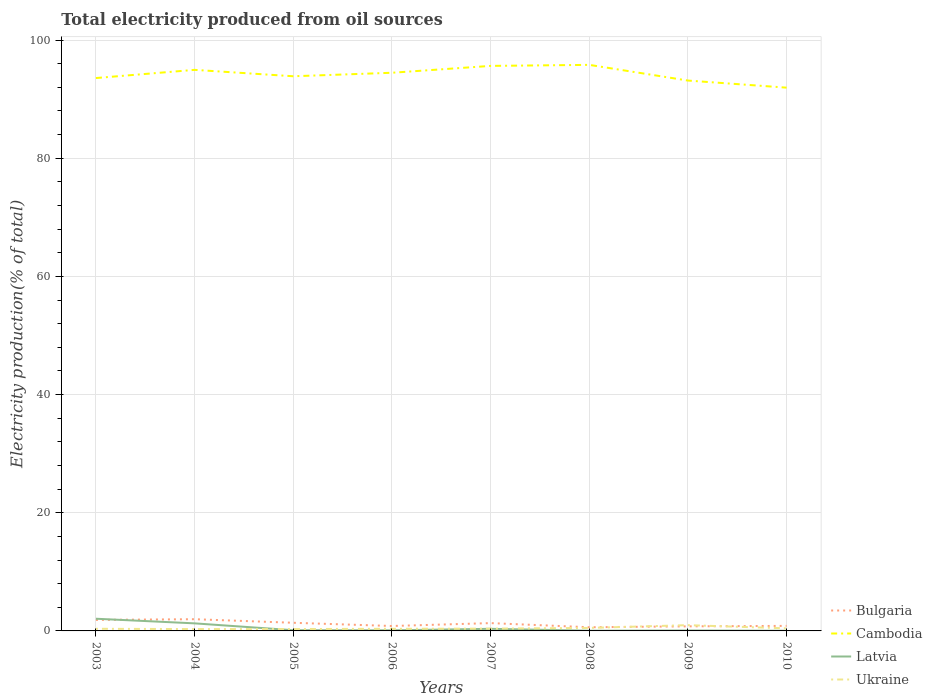How many different coloured lines are there?
Give a very brief answer. 4. Is the number of lines equal to the number of legend labels?
Provide a succinct answer. Yes. Across all years, what is the maximum total electricity produced in Latvia?
Give a very brief answer. 0.03. What is the total total electricity produced in Latvia in the graph?
Offer a very short reply. 1.96. What is the difference between the highest and the second highest total electricity produced in Latvia?
Your answer should be very brief. 2.03. Is the total electricity produced in Cambodia strictly greater than the total electricity produced in Ukraine over the years?
Your answer should be very brief. No. How many years are there in the graph?
Offer a very short reply. 8. Are the values on the major ticks of Y-axis written in scientific E-notation?
Keep it short and to the point. No. How are the legend labels stacked?
Make the answer very short. Vertical. What is the title of the graph?
Give a very brief answer. Total electricity produced from oil sources. Does "Oman" appear as one of the legend labels in the graph?
Offer a very short reply. No. What is the label or title of the X-axis?
Your answer should be very brief. Years. What is the label or title of the Y-axis?
Offer a very short reply. Electricity production(% of total). What is the Electricity production(% of total) of Bulgaria in 2003?
Provide a short and direct response. 1.86. What is the Electricity production(% of total) in Cambodia in 2003?
Offer a terse response. 93.58. What is the Electricity production(% of total) in Latvia in 2003?
Give a very brief answer. 2.06. What is the Electricity production(% of total) in Ukraine in 2003?
Offer a terse response. 0.36. What is the Electricity production(% of total) in Bulgaria in 2004?
Keep it short and to the point. 1.98. What is the Electricity production(% of total) in Cambodia in 2004?
Offer a very short reply. 94.96. What is the Electricity production(% of total) in Latvia in 2004?
Your response must be concise. 1.28. What is the Electricity production(% of total) of Ukraine in 2004?
Ensure brevity in your answer.  0.31. What is the Electricity production(% of total) in Bulgaria in 2005?
Offer a very short reply. 1.38. What is the Electricity production(% of total) in Cambodia in 2005?
Ensure brevity in your answer.  93.88. What is the Electricity production(% of total) in Latvia in 2005?
Provide a short and direct response. 0.12. What is the Electricity production(% of total) of Ukraine in 2005?
Your response must be concise. 0.32. What is the Electricity production(% of total) in Bulgaria in 2006?
Offer a very short reply. 0.83. What is the Electricity production(% of total) in Cambodia in 2006?
Make the answer very short. 94.47. What is the Electricity production(% of total) of Latvia in 2006?
Your response must be concise. 0.1. What is the Electricity production(% of total) in Ukraine in 2006?
Give a very brief answer. 0.36. What is the Electricity production(% of total) in Bulgaria in 2007?
Offer a terse response. 1.32. What is the Electricity production(% of total) of Cambodia in 2007?
Your response must be concise. 95.63. What is the Electricity production(% of total) of Latvia in 2007?
Give a very brief answer. 0.36. What is the Electricity production(% of total) of Ukraine in 2007?
Offer a terse response. 0.39. What is the Electricity production(% of total) in Bulgaria in 2008?
Your answer should be compact. 0.62. What is the Electricity production(% of total) in Cambodia in 2008?
Ensure brevity in your answer.  95.81. What is the Electricity production(% of total) of Latvia in 2008?
Make the answer very short. 0.04. What is the Electricity production(% of total) in Ukraine in 2008?
Give a very brief answer. 0.51. What is the Electricity production(% of total) of Bulgaria in 2009?
Make the answer very short. 0.77. What is the Electricity production(% of total) of Cambodia in 2009?
Offer a terse response. 93.15. What is the Electricity production(% of total) in Latvia in 2009?
Ensure brevity in your answer.  0.07. What is the Electricity production(% of total) in Ukraine in 2009?
Provide a short and direct response. 0.98. What is the Electricity production(% of total) in Bulgaria in 2010?
Offer a very short reply. 0.85. What is the Electricity production(% of total) of Cambodia in 2010?
Ensure brevity in your answer.  91.95. What is the Electricity production(% of total) in Latvia in 2010?
Give a very brief answer. 0.03. What is the Electricity production(% of total) of Ukraine in 2010?
Offer a very short reply. 0.44. Across all years, what is the maximum Electricity production(% of total) in Bulgaria?
Ensure brevity in your answer.  1.98. Across all years, what is the maximum Electricity production(% of total) in Cambodia?
Your answer should be compact. 95.81. Across all years, what is the maximum Electricity production(% of total) of Latvia?
Your answer should be very brief. 2.06. Across all years, what is the maximum Electricity production(% of total) of Ukraine?
Make the answer very short. 0.98. Across all years, what is the minimum Electricity production(% of total) of Bulgaria?
Give a very brief answer. 0.62. Across all years, what is the minimum Electricity production(% of total) in Cambodia?
Provide a succinct answer. 91.95. Across all years, what is the minimum Electricity production(% of total) of Latvia?
Your response must be concise. 0.03. Across all years, what is the minimum Electricity production(% of total) in Ukraine?
Make the answer very short. 0.31. What is the total Electricity production(% of total) in Bulgaria in the graph?
Provide a short and direct response. 9.63. What is the total Electricity production(% of total) in Cambodia in the graph?
Make the answer very short. 753.44. What is the total Electricity production(% of total) of Latvia in the graph?
Keep it short and to the point. 4.06. What is the total Electricity production(% of total) of Ukraine in the graph?
Offer a very short reply. 3.66. What is the difference between the Electricity production(% of total) in Bulgaria in 2003 and that in 2004?
Keep it short and to the point. -0.12. What is the difference between the Electricity production(% of total) in Cambodia in 2003 and that in 2004?
Ensure brevity in your answer.  -1.39. What is the difference between the Electricity production(% of total) of Latvia in 2003 and that in 2004?
Make the answer very short. 0.78. What is the difference between the Electricity production(% of total) in Ukraine in 2003 and that in 2004?
Provide a succinct answer. 0.05. What is the difference between the Electricity production(% of total) of Bulgaria in 2003 and that in 2005?
Give a very brief answer. 0.49. What is the difference between the Electricity production(% of total) of Cambodia in 2003 and that in 2005?
Provide a succinct answer. -0.3. What is the difference between the Electricity production(% of total) in Latvia in 2003 and that in 2005?
Offer a very short reply. 1.94. What is the difference between the Electricity production(% of total) of Ukraine in 2003 and that in 2005?
Offer a very short reply. 0.05. What is the difference between the Electricity production(% of total) in Bulgaria in 2003 and that in 2006?
Offer a terse response. 1.03. What is the difference between the Electricity production(% of total) of Cambodia in 2003 and that in 2006?
Ensure brevity in your answer.  -0.89. What is the difference between the Electricity production(% of total) of Latvia in 2003 and that in 2006?
Your answer should be compact. 1.96. What is the difference between the Electricity production(% of total) of Ukraine in 2003 and that in 2006?
Your answer should be very brief. 0. What is the difference between the Electricity production(% of total) of Bulgaria in 2003 and that in 2007?
Your answer should be very brief. 0.54. What is the difference between the Electricity production(% of total) of Cambodia in 2003 and that in 2007?
Your response must be concise. -2.06. What is the difference between the Electricity production(% of total) in Latvia in 2003 and that in 2007?
Provide a short and direct response. 1.71. What is the difference between the Electricity production(% of total) in Ukraine in 2003 and that in 2007?
Ensure brevity in your answer.  -0.03. What is the difference between the Electricity production(% of total) in Bulgaria in 2003 and that in 2008?
Make the answer very short. 1.24. What is the difference between the Electricity production(% of total) of Cambodia in 2003 and that in 2008?
Make the answer very short. -2.23. What is the difference between the Electricity production(% of total) of Latvia in 2003 and that in 2008?
Offer a terse response. 2.02. What is the difference between the Electricity production(% of total) in Ukraine in 2003 and that in 2008?
Make the answer very short. -0.15. What is the difference between the Electricity production(% of total) in Bulgaria in 2003 and that in 2009?
Offer a terse response. 1.09. What is the difference between the Electricity production(% of total) of Cambodia in 2003 and that in 2009?
Provide a short and direct response. 0.43. What is the difference between the Electricity production(% of total) in Latvia in 2003 and that in 2009?
Keep it short and to the point. 1.99. What is the difference between the Electricity production(% of total) of Ukraine in 2003 and that in 2009?
Your answer should be compact. -0.61. What is the difference between the Electricity production(% of total) of Bulgaria in 2003 and that in 2010?
Give a very brief answer. 1.01. What is the difference between the Electricity production(% of total) in Cambodia in 2003 and that in 2010?
Offer a terse response. 1.63. What is the difference between the Electricity production(% of total) of Latvia in 2003 and that in 2010?
Offer a terse response. 2.03. What is the difference between the Electricity production(% of total) in Ukraine in 2003 and that in 2010?
Make the answer very short. -0.08. What is the difference between the Electricity production(% of total) in Bulgaria in 2004 and that in 2005?
Ensure brevity in your answer.  0.61. What is the difference between the Electricity production(% of total) in Cambodia in 2004 and that in 2005?
Keep it short and to the point. 1.08. What is the difference between the Electricity production(% of total) of Latvia in 2004 and that in 2005?
Provide a succinct answer. 1.16. What is the difference between the Electricity production(% of total) of Ukraine in 2004 and that in 2005?
Offer a very short reply. -0. What is the difference between the Electricity production(% of total) in Bulgaria in 2004 and that in 2006?
Give a very brief answer. 1.15. What is the difference between the Electricity production(% of total) in Cambodia in 2004 and that in 2006?
Provide a succinct answer. 0.49. What is the difference between the Electricity production(% of total) in Latvia in 2004 and that in 2006?
Provide a short and direct response. 1.18. What is the difference between the Electricity production(% of total) of Ukraine in 2004 and that in 2006?
Give a very brief answer. -0.05. What is the difference between the Electricity production(% of total) in Bulgaria in 2004 and that in 2007?
Your answer should be compact. 0.66. What is the difference between the Electricity production(% of total) in Cambodia in 2004 and that in 2007?
Your answer should be very brief. -0.67. What is the difference between the Electricity production(% of total) in Latvia in 2004 and that in 2007?
Your response must be concise. 0.92. What is the difference between the Electricity production(% of total) of Ukraine in 2004 and that in 2007?
Provide a succinct answer. -0.07. What is the difference between the Electricity production(% of total) in Bulgaria in 2004 and that in 2008?
Ensure brevity in your answer.  1.36. What is the difference between the Electricity production(% of total) in Cambodia in 2004 and that in 2008?
Give a very brief answer. -0.84. What is the difference between the Electricity production(% of total) in Latvia in 2004 and that in 2008?
Provide a short and direct response. 1.24. What is the difference between the Electricity production(% of total) of Ukraine in 2004 and that in 2008?
Your response must be concise. -0.2. What is the difference between the Electricity production(% of total) in Bulgaria in 2004 and that in 2009?
Offer a terse response. 1.21. What is the difference between the Electricity production(% of total) of Cambodia in 2004 and that in 2009?
Ensure brevity in your answer.  1.81. What is the difference between the Electricity production(% of total) in Latvia in 2004 and that in 2009?
Provide a succinct answer. 1.21. What is the difference between the Electricity production(% of total) in Ukraine in 2004 and that in 2009?
Your response must be concise. -0.66. What is the difference between the Electricity production(% of total) in Bulgaria in 2004 and that in 2010?
Give a very brief answer. 1.13. What is the difference between the Electricity production(% of total) of Cambodia in 2004 and that in 2010?
Provide a succinct answer. 3.01. What is the difference between the Electricity production(% of total) in Latvia in 2004 and that in 2010?
Provide a short and direct response. 1.25. What is the difference between the Electricity production(% of total) of Ukraine in 2004 and that in 2010?
Give a very brief answer. -0.12. What is the difference between the Electricity production(% of total) of Bulgaria in 2005 and that in 2006?
Your response must be concise. 0.55. What is the difference between the Electricity production(% of total) of Cambodia in 2005 and that in 2006?
Offer a terse response. -0.59. What is the difference between the Electricity production(% of total) of Latvia in 2005 and that in 2006?
Your answer should be compact. 0.02. What is the difference between the Electricity production(% of total) of Ukraine in 2005 and that in 2006?
Ensure brevity in your answer.  -0.04. What is the difference between the Electricity production(% of total) in Bulgaria in 2005 and that in 2007?
Ensure brevity in your answer.  0.06. What is the difference between the Electricity production(% of total) of Cambodia in 2005 and that in 2007?
Keep it short and to the point. -1.75. What is the difference between the Electricity production(% of total) of Latvia in 2005 and that in 2007?
Make the answer very short. -0.23. What is the difference between the Electricity production(% of total) in Ukraine in 2005 and that in 2007?
Offer a very short reply. -0.07. What is the difference between the Electricity production(% of total) of Bulgaria in 2005 and that in 2008?
Your answer should be compact. 0.76. What is the difference between the Electricity production(% of total) in Cambodia in 2005 and that in 2008?
Give a very brief answer. -1.93. What is the difference between the Electricity production(% of total) of Latvia in 2005 and that in 2008?
Keep it short and to the point. 0.08. What is the difference between the Electricity production(% of total) of Ukraine in 2005 and that in 2008?
Your answer should be compact. -0.19. What is the difference between the Electricity production(% of total) in Bulgaria in 2005 and that in 2009?
Offer a very short reply. 0.6. What is the difference between the Electricity production(% of total) of Cambodia in 2005 and that in 2009?
Offer a terse response. 0.73. What is the difference between the Electricity production(% of total) in Latvia in 2005 and that in 2009?
Ensure brevity in your answer.  0.05. What is the difference between the Electricity production(% of total) in Ukraine in 2005 and that in 2009?
Your answer should be very brief. -0.66. What is the difference between the Electricity production(% of total) of Bulgaria in 2005 and that in 2010?
Your answer should be compact. 0.52. What is the difference between the Electricity production(% of total) of Cambodia in 2005 and that in 2010?
Offer a very short reply. 1.93. What is the difference between the Electricity production(% of total) of Latvia in 2005 and that in 2010?
Provide a short and direct response. 0.09. What is the difference between the Electricity production(% of total) of Ukraine in 2005 and that in 2010?
Keep it short and to the point. -0.12. What is the difference between the Electricity production(% of total) in Bulgaria in 2006 and that in 2007?
Your answer should be compact. -0.49. What is the difference between the Electricity production(% of total) of Cambodia in 2006 and that in 2007?
Make the answer very short. -1.16. What is the difference between the Electricity production(% of total) of Latvia in 2006 and that in 2007?
Make the answer very short. -0.25. What is the difference between the Electricity production(% of total) in Ukraine in 2006 and that in 2007?
Give a very brief answer. -0.03. What is the difference between the Electricity production(% of total) in Bulgaria in 2006 and that in 2008?
Give a very brief answer. 0.21. What is the difference between the Electricity production(% of total) of Cambodia in 2006 and that in 2008?
Keep it short and to the point. -1.34. What is the difference between the Electricity production(% of total) in Latvia in 2006 and that in 2008?
Keep it short and to the point. 0.06. What is the difference between the Electricity production(% of total) of Ukraine in 2006 and that in 2008?
Your answer should be compact. -0.15. What is the difference between the Electricity production(% of total) in Bulgaria in 2006 and that in 2009?
Your response must be concise. 0.06. What is the difference between the Electricity production(% of total) of Cambodia in 2006 and that in 2009?
Provide a succinct answer. 1.32. What is the difference between the Electricity production(% of total) in Latvia in 2006 and that in 2009?
Offer a very short reply. 0.03. What is the difference between the Electricity production(% of total) in Ukraine in 2006 and that in 2009?
Your answer should be compact. -0.62. What is the difference between the Electricity production(% of total) of Bulgaria in 2006 and that in 2010?
Give a very brief answer. -0.02. What is the difference between the Electricity production(% of total) in Cambodia in 2006 and that in 2010?
Offer a terse response. 2.52. What is the difference between the Electricity production(% of total) of Latvia in 2006 and that in 2010?
Give a very brief answer. 0.07. What is the difference between the Electricity production(% of total) in Ukraine in 2006 and that in 2010?
Make the answer very short. -0.08. What is the difference between the Electricity production(% of total) of Bulgaria in 2007 and that in 2008?
Give a very brief answer. 0.7. What is the difference between the Electricity production(% of total) of Cambodia in 2007 and that in 2008?
Your answer should be compact. -0.17. What is the difference between the Electricity production(% of total) in Latvia in 2007 and that in 2008?
Keep it short and to the point. 0.32. What is the difference between the Electricity production(% of total) of Ukraine in 2007 and that in 2008?
Your response must be concise. -0.12. What is the difference between the Electricity production(% of total) in Bulgaria in 2007 and that in 2009?
Offer a terse response. 0.55. What is the difference between the Electricity production(% of total) in Cambodia in 2007 and that in 2009?
Your answer should be compact. 2.48. What is the difference between the Electricity production(% of total) in Latvia in 2007 and that in 2009?
Offer a very short reply. 0.28. What is the difference between the Electricity production(% of total) of Ukraine in 2007 and that in 2009?
Your response must be concise. -0.59. What is the difference between the Electricity production(% of total) of Bulgaria in 2007 and that in 2010?
Your answer should be compact. 0.47. What is the difference between the Electricity production(% of total) of Cambodia in 2007 and that in 2010?
Offer a terse response. 3.68. What is the difference between the Electricity production(% of total) in Latvia in 2007 and that in 2010?
Offer a terse response. 0.33. What is the difference between the Electricity production(% of total) of Ukraine in 2007 and that in 2010?
Your response must be concise. -0.05. What is the difference between the Electricity production(% of total) in Bulgaria in 2008 and that in 2009?
Offer a very short reply. -0.15. What is the difference between the Electricity production(% of total) of Cambodia in 2008 and that in 2009?
Your answer should be compact. 2.66. What is the difference between the Electricity production(% of total) of Latvia in 2008 and that in 2009?
Offer a terse response. -0.03. What is the difference between the Electricity production(% of total) of Ukraine in 2008 and that in 2009?
Your response must be concise. -0.47. What is the difference between the Electricity production(% of total) in Bulgaria in 2008 and that in 2010?
Make the answer very short. -0.23. What is the difference between the Electricity production(% of total) in Cambodia in 2008 and that in 2010?
Offer a terse response. 3.86. What is the difference between the Electricity production(% of total) of Latvia in 2008 and that in 2010?
Your answer should be compact. 0.01. What is the difference between the Electricity production(% of total) of Ukraine in 2008 and that in 2010?
Offer a very short reply. 0.07. What is the difference between the Electricity production(% of total) in Bulgaria in 2009 and that in 2010?
Your response must be concise. -0.08. What is the difference between the Electricity production(% of total) of Cambodia in 2009 and that in 2010?
Your answer should be very brief. 1.2. What is the difference between the Electricity production(% of total) in Latvia in 2009 and that in 2010?
Your answer should be compact. 0.04. What is the difference between the Electricity production(% of total) in Ukraine in 2009 and that in 2010?
Your answer should be very brief. 0.54. What is the difference between the Electricity production(% of total) in Bulgaria in 2003 and the Electricity production(% of total) in Cambodia in 2004?
Your answer should be very brief. -93.1. What is the difference between the Electricity production(% of total) of Bulgaria in 2003 and the Electricity production(% of total) of Latvia in 2004?
Your answer should be compact. 0.58. What is the difference between the Electricity production(% of total) of Bulgaria in 2003 and the Electricity production(% of total) of Ukraine in 2004?
Provide a short and direct response. 1.55. What is the difference between the Electricity production(% of total) of Cambodia in 2003 and the Electricity production(% of total) of Latvia in 2004?
Your response must be concise. 92.3. What is the difference between the Electricity production(% of total) of Cambodia in 2003 and the Electricity production(% of total) of Ukraine in 2004?
Keep it short and to the point. 93.26. What is the difference between the Electricity production(% of total) of Latvia in 2003 and the Electricity production(% of total) of Ukraine in 2004?
Give a very brief answer. 1.75. What is the difference between the Electricity production(% of total) of Bulgaria in 2003 and the Electricity production(% of total) of Cambodia in 2005?
Your answer should be very brief. -92.02. What is the difference between the Electricity production(% of total) in Bulgaria in 2003 and the Electricity production(% of total) in Latvia in 2005?
Provide a succinct answer. 1.74. What is the difference between the Electricity production(% of total) in Bulgaria in 2003 and the Electricity production(% of total) in Ukraine in 2005?
Provide a succinct answer. 1.55. What is the difference between the Electricity production(% of total) in Cambodia in 2003 and the Electricity production(% of total) in Latvia in 2005?
Provide a succinct answer. 93.46. What is the difference between the Electricity production(% of total) in Cambodia in 2003 and the Electricity production(% of total) in Ukraine in 2005?
Your answer should be compact. 93.26. What is the difference between the Electricity production(% of total) in Latvia in 2003 and the Electricity production(% of total) in Ukraine in 2005?
Offer a terse response. 1.75. What is the difference between the Electricity production(% of total) of Bulgaria in 2003 and the Electricity production(% of total) of Cambodia in 2006?
Keep it short and to the point. -92.61. What is the difference between the Electricity production(% of total) in Bulgaria in 2003 and the Electricity production(% of total) in Latvia in 2006?
Give a very brief answer. 1.76. What is the difference between the Electricity production(% of total) in Bulgaria in 2003 and the Electricity production(% of total) in Ukraine in 2006?
Offer a terse response. 1.5. What is the difference between the Electricity production(% of total) in Cambodia in 2003 and the Electricity production(% of total) in Latvia in 2006?
Offer a very short reply. 93.48. What is the difference between the Electricity production(% of total) of Cambodia in 2003 and the Electricity production(% of total) of Ukraine in 2006?
Provide a short and direct response. 93.22. What is the difference between the Electricity production(% of total) in Latvia in 2003 and the Electricity production(% of total) in Ukraine in 2006?
Make the answer very short. 1.7. What is the difference between the Electricity production(% of total) in Bulgaria in 2003 and the Electricity production(% of total) in Cambodia in 2007?
Offer a very short reply. -93.77. What is the difference between the Electricity production(% of total) in Bulgaria in 2003 and the Electricity production(% of total) in Latvia in 2007?
Provide a succinct answer. 1.51. What is the difference between the Electricity production(% of total) in Bulgaria in 2003 and the Electricity production(% of total) in Ukraine in 2007?
Your answer should be very brief. 1.48. What is the difference between the Electricity production(% of total) of Cambodia in 2003 and the Electricity production(% of total) of Latvia in 2007?
Offer a terse response. 93.22. What is the difference between the Electricity production(% of total) in Cambodia in 2003 and the Electricity production(% of total) in Ukraine in 2007?
Your answer should be very brief. 93.19. What is the difference between the Electricity production(% of total) in Latvia in 2003 and the Electricity production(% of total) in Ukraine in 2007?
Offer a very short reply. 1.68. What is the difference between the Electricity production(% of total) in Bulgaria in 2003 and the Electricity production(% of total) in Cambodia in 2008?
Keep it short and to the point. -93.94. What is the difference between the Electricity production(% of total) of Bulgaria in 2003 and the Electricity production(% of total) of Latvia in 2008?
Your answer should be compact. 1.83. What is the difference between the Electricity production(% of total) of Bulgaria in 2003 and the Electricity production(% of total) of Ukraine in 2008?
Keep it short and to the point. 1.35. What is the difference between the Electricity production(% of total) of Cambodia in 2003 and the Electricity production(% of total) of Latvia in 2008?
Ensure brevity in your answer.  93.54. What is the difference between the Electricity production(% of total) of Cambodia in 2003 and the Electricity production(% of total) of Ukraine in 2008?
Offer a very short reply. 93.07. What is the difference between the Electricity production(% of total) of Latvia in 2003 and the Electricity production(% of total) of Ukraine in 2008?
Provide a short and direct response. 1.55. What is the difference between the Electricity production(% of total) in Bulgaria in 2003 and the Electricity production(% of total) in Cambodia in 2009?
Your response must be concise. -91.29. What is the difference between the Electricity production(% of total) of Bulgaria in 2003 and the Electricity production(% of total) of Latvia in 2009?
Your response must be concise. 1.79. What is the difference between the Electricity production(% of total) in Bulgaria in 2003 and the Electricity production(% of total) in Ukraine in 2009?
Offer a terse response. 0.89. What is the difference between the Electricity production(% of total) in Cambodia in 2003 and the Electricity production(% of total) in Latvia in 2009?
Give a very brief answer. 93.51. What is the difference between the Electricity production(% of total) of Cambodia in 2003 and the Electricity production(% of total) of Ukraine in 2009?
Provide a succinct answer. 92.6. What is the difference between the Electricity production(% of total) in Latvia in 2003 and the Electricity production(% of total) in Ukraine in 2009?
Provide a short and direct response. 1.09. What is the difference between the Electricity production(% of total) of Bulgaria in 2003 and the Electricity production(% of total) of Cambodia in 2010?
Provide a short and direct response. -90.09. What is the difference between the Electricity production(% of total) in Bulgaria in 2003 and the Electricity production(% of total) in Latvia in 2010?
Provide a short and direct response. 1.83. What is the difference between the Electricity production(% of total) in Bulgaria in 2003 and the Electricity production(% of total) in Ukraine in 2010?
Keep it short and to the point. 1.43. What is the difference between the Electricity production(% of total) in Cambodia in 2003 and the Electricity production(% of total) in Latvia in 2010?
Provide a succinct answer. 93.55. What is the difference between the Electricity production(% of total) in Cambodia in 2003 and the Electricity production(% of total) in Ukraine in 2010?
Ensure brevity in your answer.  93.14. What is the difference between the Electricity production(% of total) in Latvia in 2003 and the Electricity production(% of total) in Ukraine in 2010?
Your answer should be very brief. 1.63. What is the difference between the Electricity production(% of total) of Bulgaria in 2004 and the Electricity production(% of total) of Cambodia in 2005?
Keep it short and to the point. -91.9. What is the difference between the Electricity production(% of total) of Bulgaria in 2004 and the Electricity production(% of total) of Latvia in 2005?
Provide a short and direct response. 1.86. What is the difference between the Electricity production(% of total) of Bulgaria in 2004 and the Electricity production(% of total) of Ukraine in 2005?
Give a very brief answer. 1.67. What is the difference between the Electricity production(% of total) in Cambodia in 2004 and the Electricity production(% of total) in Latvia in 2005?
Provide a succinct answer. 94.84. What is the difference between the Electricity production(% of total) of Cambodia in 2004 and the Electricity production(% of total) of Ukraine in 2005?
Give a very brief answer. 94.65. What is the difference between the Electricity production(% of total) in Latvia in 2004 and the Electricity production(% of total) in Ukraine in 2005?
Your answer should be very brief. 0.96. What is the difference between the Electricity production(% of total) in Bulgaria in 2004 and the Electricity production(% of total) in Cambodia in 2006?
Your response must be concise. -92.49. What is the difference between the Electricity production(% of total) in Bulgaria in 2004 and the Electricity production(% of total) in Latvia in 2006?
Your answer should be compact. 1.88. What is the difference between the Electricity production(% of total) of Bulgaria in 2004 and the Electricity production(% of total) of Ukraine in 2006?
Your response must be concise. 1.62. What is the difference between the Electricity production(% of total) in Cambodia in 2004 and the Electricity production(% of total) in Latvia in 2006?
Provide a succinct answer. 94.86. What is the difference between the Electricity production(% of total) of Cambodia in 2004 and the Electricity production(% of total) of Ukraine in 2006?
Your response must be concise. 94.6. What is the difference between the Electricity production(% of total) of Latvia in 2004 and the Electricity production(% of total) of Ukraine in 2006?
Keep it short and to the point. 0.92. What is the difference between the Electricity production(% of total) in Bulgaria in 2004 and the Electricity production(% of total) in Cambodia in 2007?
Make the answer very short. -93.65. What is the difference between the Electricity production(% of total) of Bulgaria in 2004 and the Electricity production(% of total) of Latvia in 2007?
Provide a succinct answer. 1.63. What is the difference between the Electricity production(% of total) of Bulgaria in 2004 and the Electricity production(% of total) of Ukraine in 2007?
Offer a very short reply. 1.6. What is the difference between the Electricity production(% of total) in Cambodia in 2004 and the Electricity production(% of total) in Latvia in 2007?
Your response must be concise. 94.61. What is the difference between the Electricity production(% of total) in Cambodia in 2004 and the Electricity production(% of total) in Ukraine in 2007?
Your response must be concise. 94.58. What is the difference between the Electricity production(% of total) in Latvia in 2004 and the Electricity production(% of total) in Ukraine in 2007?
Your answer should be compact. 0.89. What is the difference between the Electricity production(% of total) in Bulgaria in 2004 and the Electricity production(% of total) in Cambodia in 2008?
Your response must be concise. -93.82. What is the difference between the Electricity production(% of total) in Bulgaria in 2004 and the Electricity production(% of total) in Latvia in 2008?
Give a very brief answer. 1.95. What is the difference between the Electricity production(% of total) in Bulgaria in 2004 and the Electricity production(% of total) in Ukraine in 2008?
Offer a terse response. 1.47. What is the difference between the Electricity production(% of total) in Cambodia in 2004 and the Electricity production(% of total) in Latvia in 2008?
Make the answer very short. 94.93. What is the difference between the Electricity production(% of total) in Cambodia in 2004 and the Electricity production(% of total) in Ukraine in 2008?
Provide a succinct answer. 94.45. What is the difference between the Electricity production(% of total) of Latvia in 2004 and the Electricity production(% of total) of Ukraine in 2008?
Your response must be concise. 0.77. What is the difference between the Electricity production(% of total) in Bulgaria in 2004 and the Electricity production(% of total) in Cambodia in 2009?
Make the answer very short. -91.17. What is the difference between the Electricity production(% of total) of Bulgaria in 2004 and the Electricity production(% of total) of Latvia in 2009?
Give a very brief answer. 1.91. What is the difference between the Electricity production(% of total) in Bulgaria in 2004 and the Electricity production(% of total) in Ukraine in 2009?
Ensure brevity in your answer.  1.01. What is the difference between the Electricity production(% of total) in Cambodia in 2004 and the Electricity production(% of total) in Latvia in 2009?
Ensure brevity in your answer.  94.89. What is the difference between the Electricity production(% of total) in Cambodia in 2004 and the Electricity production(% of total) in Ukraine in 2009?
Provide a short and direct response. 93.99. What is the difference between the Electricity production(% of total) of Latvia in 2004 and the Electricity production(% of total) of Ukraine in 2009?
Make the answer very short. 0.3. What is the difference between the Electricity production(% of total) in Bulgaria in 2004 and the Electricity production(% of total) in Cambodia in 2010?
Your answer should be compact. -89.97. What is the difference between the Electricity production(% of total) in Bulgaria in 2004 and the Electricity production(% of total) in Latvia in 2010?
Make the answer very short. 1.95. What is the difference between the Electricity production(% of total) of Bulgaria in 2004 and the Electricity production(% of total) of Ukraine in 2010?
Offer a terse response. 1.55. What is the difference between the Electricity production(% of total) of Cambodia in 2004 and the Electricity production(% of total) of Latvia in 2010?
Give a very brief answer. 94.93. What is the difference between the Electricity production(% of total) of Cambodia in 2004 and the Electricity production(% of total) of Ukraine in 2010?
Offer a very short reply. 94.53. What is the difference between the Electricity production(% of total) in Latvia in 2004 and the Electricity production(% of total) in Ukraine in 2010?
Offer a very short reply. 0.84. What is the difference between the Electricity production(% of total) of Bulgaria in 2005 and the Electricity production(% of total) of Cambodia in 2006?
Your answer should be compact. -93.09. What is the difference between the Electricity production(% of total) of Bulgaria in 2005 and the Electricity production(% of total) of Latvia in 2006?
Keep it short and to the point. 1.28. What is the difference between the Electricity production(% of total) in Bulgaria in 2005 and the Electricity production(% of total) in Ukraine in 2006?
Your answer should be compact. 1.02. What is the difference between the Electricity production(% of total) of Cambodia in 2005 and the Electricity production(% of total) of Latvia in 2006?
Ensure brevity in your answer.  93.78. What is the difference between the Electricity production(% of total) of Cambodia in 2005 and the Electricity production(% of total) of Ukraine in 2006?
Provide a succinct answer. 93.52. What is the difference between the Electricity production(% of total) of Latvia in 2005 and the Electricity production(% of total) of Ukraine in 2006?
Your response must be concise. -0.24. What is the difference between the Electricity production(% of total) in Bulgaria in 2005 and the Electricity production(% of total) in Cambodia in 2007?
Provide a short and direct response. -94.26. What is the difference between the Electricity production(% of total) of Bulgaria in 2005 and the Electricity production(% of total) of Latvia in 2007?
Make the answer very short. 1.02. What is the difference between the Electricity production(% of total) of Bulgaria in 2005 and the Electricity production(% of total) of Ukraine in 2007?
Provide a short and direct response. 0.99. What is the difference between the Electricity production(% of total) in Cambodia in 2005 and the Electricity production(% of total) in Latvia in 2007?
Offer a very short reply. 93.52. What is the difference between the Electricity production(% of total) of Cambodia in 2005 and the Electricity production(% of total) of Ukraine in 2007?
Your answer should be very brief. 93.49. What is the difference between the Electricity production(% of total) in Latvia in 2005 and the Electricity production(% of total) in Ukraine in 2007?
Your answer should be compact. -0.26. What is the difference between the Electricity production(% of total) of Bulgaria in 2005 and the Electricity production(% of total) of Cambodia in 2008?
Your response must be concise. -94.43. What is the difference between the Electricity production(% of total) in Bulgaria in 2005 and the Electricity production(% of total) in Latvia in 2008?
Your response must be concise. 1.34. What is the difference between the Electricity production(% of total) in Bulgaria in 2005 and the Electricity production(% of total) in Ukraine in 2008?
Your answer should be very brief. 0.87. What is the difference between the Electricity production(% of total) of Cambodia in 2005 and the Electricity production(% of total) of Latvia in 2008?
Keep it short and to the point. 93.84. What is the difference between the Electricity production(% of total) of Cambodia in 2005 and the Electricity production(% of total) of Ukraine in 2008?
Your response must be concise. 93.37. What is the difference between the Electricity production(% of total) in Latvia in 2005 and the Electricity production(% of total) in Ukraine in 2008?
Your answer should be compact. -0.39. What is the difference between the Electricity production(% of total) of Bulgaria in 2005 and the Electricity production(% of total) of Cambodia in 2009?
Offer a very short reply. -91.77. What is the difference between the Electricity production(% of total) of Bulgaria in 2005 and the Electricity production(% of total) of Latvia in 2009?
Your response must be concise. 1.31. What is the difference between the Electricity production(% of total) in Bulgaria in 2005 and the Electricity production(% of total) in Ukraine in 2009?
Provide a succinct answer. 0.4. What is the difference between the Electricity production(% of total) of Cambodia in 2005 and the Electricity production(% of total) of Latvia in 2009?
Your response must be concise. 93.81. What is the difference between the Electricity production(% of total) in Cambodia in 2005 and the Electricity production(% of total) in Ukraine in 2009?
Make the answer very short. 92.9. What is the difference between the Electricity production(% of total) of Latvia in 2005 and the Electricity production(% of total) of Ukraine in 2009?
Your answer should be very brief. -0.85. What is the difference between the Electricity production(% of total) of Bulgaria in 2005 and the Electricity production(% of total) of Cambodia in 2010?
Offer a very short reply. -90.57. What is the difference between the Electricity production(% of total) of Bulgaria in 2005 and the Electricity production(% of total) of Latvia in 2010?
Make the answer very short. 1.35. What is the difference between the Electricity production(% of total) of Bulgaria in 2005 and the Electricity production(% of total) of Ukraine in 2010?
Your response must be concise. 0.94. What is the difference between the Electricity production(% of total) of Cambodia in 2005 and the Electricity production(% of total) of Latvia in 2010?
Give a very brief answer. 93.85. What is the difference between the Electricity production(% of total) of Cambodia in 2005 and the Electricity production(% of total) of Ukraine in 2010?
Your response must be concise. 93.44. What is the difference between the Electricity production(% of total) of Latvia in 2005 and the Electricity production(% of total) of Ukraine in 2010?
Make the answer very short. -0.31. What is the difference between the Electricity production(% of total) of Bulgaria in 2006 and the Electricity production(% of total) of Cambodia in 2007?
Offer a terse response. -94.8. What is the difference between the Electricity production(% of total) in Bulgaria in 2006 and the Electricity production(% of total) in Latvia in 2007?
Your answer should be very brief. 0.48. What is the difference between the Electricity production(% of total) in Bulgaria in 2006 and the Electricity production(% of total) in Ukraine in 2007?
Make the answer very short. 0.45. What is the difference between the Electricity production(% of total) of Cambodia in 2006 and the Electricity production(% of total) of Latvia in 2007?
Your answer should be compact. 94.12. What is the difference between the Electricity production(% of total) of Cambodia in 2006 and the Electricity production(% of total) of Ukraine in 2007?
Your answer should be compact. 94.09. What is the difference between the Electricity production(% of total) of Latvia in 2006 and the Electricity production(% of total) of Ukraine in 2007?
Provide a succinct answer. -0.28. What is the difference between the Electricity production(% of total) in Bulgaria in 2006 and the Electricity production(% of total) in Cambodia in 2008?
Provide a short and direct response. -94.97. What is the difference between the Electricity production(% of total) of Bulgaria in 2006 and the Electricity production(% of total) of Latvia in 2008?
Give a very brief answer. 0.8. What is the difference between the Electricity production(% of total) of Bulgaria in 2006 and the Electricity production(% of total) of Ukraine in 2008?
Provide a succinct answer. 0.32. What is the difference between the Electricity production(% of total) in Cambodia in 2006 and the Electricity production(% of total) in Latvia in 2008?
Your answer should be very brief. 94.43. What is the difference between the Electricity production(% of total) in Cambodia in 2006 and the Electricity production(% of total) in Ukraine in 2008?
Offer a terse response. 93.96. What is the difference between the Electricity production(% of total) of Latvia in 2006 and the Electricity production(% of total) of Ukraine in 2008?
Your answer should be compact. -0.41. What is the difference between the Electricity production(% of total) of Bulgaria in 2006 and the Electricity production(% of total) of Cambodia in 2009?
Your answer should be very brief. -92.32. What is the difference between the Electricity production(% of total) of Bulgaria in 2006 and the Electricity production(% of total) of Latvia in 2009?
Keep it short and to the point. 0.76. What is the difference between the Electricity production(% of total) of Bulgaria in 2006 and the Electricity production(% of total) of Ukraine in 2009?
Make the answer very short. -0.14. What is the difference between the Electricity production(% of total) in Cambodia in 2006 and the Electricity production(% of total) in Latvia in 2009?
Provide a short and direct response. 94.4. What is the difference between the Electricity production(% of total) of Cambodia in 2006 and the Electricity production(% of total) of Ukraine in 2009?
Ensure brevity in your answer.  93.5. What is the difference between the Electricity production(% of total) of Latvia in 2006 and the Electricity production(% of total) of Ukraine in 2009?
Keep it short and to the point. -0.87. What is the difference between the Electricity production(% of total) in Bulgaria in 2006 and the Electricity production(% of total) in Cambodia in 2010?
Your answer should be very brief. -91.12. What is the difference between the Electricity production(% of total) of Bulgaria in 2006 and the Electricity production(% of total) of Latvia in 2010?
Your answer should be very brief. 0.8. What is the difference between the Electricity production(% of total) in Bulgaria in 2006 and the Electricity production(% of total) in Ukraine in 2010?
Offer a very short reply. 0.4. What is the difference between the Electricity production(% of total) of Cambodia in 2006 and the Electricity production(% of total) of Latvia in 2010?
Offer a very short reply. 94.44. What is the difference between the Electricity production(% of total) in Cambodia in 2006 and the Electricity production(% of total) in Ukraine in 2010?
Provide a succinct answer. 94.04. What is the difference between the Electricity production(% of total) of Latvia in 2006 and the Electricity production(% of total) of Ukraine in 2010?
Offer a very short reply. -0.33. What is the difference between the Electricity production(% of total) in Bulgaria in 2007 and the Electricity production(% of total) in Cambodia in 2008?
Provide a short and direct response. -94.49. What is the difference between the Electricity production(% of total) in Bulgaria in 2007 and the Electricity production(% of total) in Latvia in 2008?
Offer a terse response. 1.28. What is the difference between the Electricity production(% of total) in Bulgaria in 2007 and the Electricity production(% of total) in Ukraine in 2008?
Provide a short and direct response. 0.81. What is the difference between the Electricity production(% of total) in Cambodia in 2007 and the Electricity production(% of total) in Latvia in 2008?
Your answer should be very brief. 95.6. What is the difference between the Electricity production(% of total) of Cambodia in 2007 and the Electricity production(% of total) of Ukraine in 2008?
Give a very brief answer. 95.12. What is the difference between the Electricity production(% of total) in Latvia in 2007 and the Electricity production(% of total) in Ukraine in 2008?
Ensure brevity in your answer.  -0.15. What is the difference between the Electricity production(% of total) of Bulgaria in 2007 and the Electricity production(% of total) of Cambodia in 2009?
Keep it short and to the point. -91.83. What is the difference between the Electricity production(% of total) of Bulgaria in 2007 and the Electricity production(% of total) of Latvia in 2009?
Provide a short and direct response. 1.25. What is the difference between the Electricity production(% of total) in Bulgaria in 2007 and the Electricity production(% of total) in Ukraine in 2009?
Your answer should be compact. 0.35. What is the difference between the Electricity production(% of total) in Cambodia in 2007 and the Electricity production(% of total) in Latvia in 2009?
Your answer should be compact. 95.56. What is the difference between the Electricity production(% of total) in Cambodia in 2007 and the Electricity production(% of total) in Ukraine in 2009?
Your response must be concise. 94.66. What is the difference between the Electricity production(% of total) in Latvia in 2007 and the Electricity production(% of total) in Ukraine in 2009?
Offer a very short reply. -0.62. What is the difference between the Electricity production(% of total) of Bulgaria in 2007 and the Electricity production(% of total) of Cambodia in 2010?
Keep it short and to the point. -90.63. What is the difference between the Electricity production(% of total) in Bulgaria in 2007 and the Electricity production(% of total) in Latvia in 2010?
Make the answer very short. 1.29. What is the difference between the Electricity production(% of total) in Bulgaria in 2007 and the Electricity production(% of total) in Ukraine in 2010?
Your response must be concise. 0.89. What is the difference between the Electricity production(% of total) in Cambodia in 2007 and the Electricity production(% of total) in Latvia in 2010?
Give a very brief answer. 95.6. What is the difference between the Electricity production(% of total) of Cambodia in 2007 and the Electricity production(% of total) of Ukraine in 2010?
Offer a terse response. 95.2. What is the difference between the Electricity production(% of total) of Latvia in 2007 and the Electricity production(% of total) of Ukraine in 2010?
Provide a succinct answer. -0.08. What is the difference between the Electricity production(% of total) of Bulgaria in 2008 and the Electricity production(% of total) of Cambodia in 2009?
Keep it short and to the point. -92.53. What is the difference between the Electricity production(% of total) of Bulgaria in 2008 and the Electricity production(% of total) of Latvia in 2009?
Your response must be concise. 0.55. What is the difference between the Electricity production(% of total) of Bulgaria in 2008 and the Electricity production(% of total) of Ukraine in 2009?
Give a very brief answer. -0.35. What is the difference between the Electricity production(% of total) of Cambodia in 2008 and the Electricity production(% of total) of Latvia in 2009?
Offer a very short reply. 95.74. What is the difference between the Electricity production(% of total) of Cambodia in 2008 and the Electricity production(% of total) of Ukraine in 2009?
Ensure brevity in your answer.  94.83. What is the difference between the Electricity production(% of total) of Latvia in 2008 and the Electricity production(% of total) of Ukraine in 2009?
Your answer should be compact. -0.94. What is the difference between the Electricity production(% of total) of Bulgaria in 2008 and the Electricity production(% of total) of Cambodia in 2010?
Your response must be concise. -91.33. What is the difference between the Electricity production(% of total) of Bulgaria in 2008 and the Electricity production(% of total) of Latvia in 2010?
Keep it short and to the point. 0.59. What is the difference between the Electricity production(% of total) of Bulgaria in 2008 and the Electricity production(% of total) of Ukraine in 2010?
Keep it short and to the point. 0.19. What is the difference between the Electricity production(% of total) in Cambodia in 2008 and the Electricity production(% of total) in Latvia in 2010?
Keep it short and to the point. 95.78. What is the difference between the Electricity production(% of total) of Cambodia in 2008 and the Electricity production(% of total) of Ukraine in 2010?
Provide a short and direct response. 95.37. What is the difference between the Electricity production(% of total) of Latvia in 2008 and the Electricity production(% of total) of Ukraine in 2010?
Offer a very short reply. -0.4. What is the difference between the Electricity production(% of total) in Bulgaria in 2009 and the Electricity production(% of total) in Cambodia in 2010?
Offer a terse response. -91.18. What is the difference between the Electricity production(% of total) of Bulgaria in 2009 and the Electricity production(% of total) of Latvia in 2010?
Ensure brevity in your answer.  0.74. What is the difference between the Electricity production(% of total) in Bulgaria in 2009 and the Electricity production(% of total) in Ukraine in 2010?
Offer a very short reply. 0.34. What is the difference between the Electricity production(% of total) of Cambodia in 2009 and the Electricity production(% of total) of Latvia in 2010?
Give a very brief answer. 93.12. What is the difference between the Electricity production(% of total) of Cambodia in 2009 and the Electricity production(% of total) of Ukraine in 2010?
Keep it short and to the point. 92.72. What is the difference between the Electricity production(% of total) of Latvia in 2009 and the Electricity production(% of total) of Ukraine in 2010?
Provide a succinct answer. -0.36. What is the average Electricity production(% of total) in Bulgaria per year?
Make the answer very short. 1.2. What is the average Electricity production(% of total) of Cambodia per year?
Offer a terse response. 94.18. What is the average Electricity production(% of total) in Latvia per year?
Your response must be concise. 0.51. What is the average Electricity production(% of total) in Ukraine per year?
Offer a terse response. 0.46. In the year 2003, what is the difference between the Electricity production(% of total) of Bulgaria and Electricity production(% of total) of Cambodia?
Keep it short and to the point. -91.71. In the year 2003, what is the difference between the Electricity production(% of total) of Bulgaria and Electricity production(% of total) of Latvia?
Make the answer very short. -0.2. In the year 2003, what is the difference between the Electricity production(% of total) in Bulgaria and Electricity production(% of total) in Ukraine?
Make the answer very short. 1.5. In the year 2003, what is the difference between the Electricity production(% of total) in Cambodia and Electricity production(% of total) in Latvia?
Your answer should be very brief. 91.52. In the year 2003, what is the difference between the Electricity production(% of total) in Cambodia and Electricity production(% of total) in Ukraine?
Offer a very short reply. 93.22. In the year 2003, what is the difference between the Electricity production(% of total) in Latvia and Electricity production(% of total) in Ukraine?
Provide a succinct answer. 1.7. In the year 2004, what is the difference between the Electricity production(% of total) of Bulgaria and Electricity production(% of total) of Cambodia?
Ensure brevity in your answer.  -92.98. In the year 2004, what is the difference between the Electricity production(% of total) of Bulgaria and Electricity production(% of total) of Latvia?
Give a very brief answer. 0.7. In the year 2004, what is the difference between the Electricity production(% of total) of Bulgaria and Electricity production(% of total) of Ukraine?
Your answer should be very brief. 1.67. In the year 2004, what is the difference between the Electricity production(% of total) of Cambodia and Electricity production(% of total) of Latvia?
Your answer should be very brief. 93.68. In the year 2004, what is the difference between the Electricity production(% of total) in Cambodia and Electricity production(% of total) in Ukraine?
Give a very brief answer. 94.65. In the year 2004, what is the difference between the Electricity production(% of total) of Latvia and Electricity production(% of total) of Ukraine?
Keep it short and to the point. 0.97. In the year 2005, what is the difference between the Electricity production(% of total) in Bulgaria and Electricity production(% of total) in Cambodia?
Ensure brevity in your answer.  -92.5. In the year 2005, what is the difference between the Electricity production(% of total) of Bulgaria and Electricity production(% of total) of Latvia?
Provide a short and direct response. 1.26. In the year 2005, what is the difference between the Electricity production(% of total) of Bulgaria and Electricity production(% of total) of Ukraine?
Offer a terse response. 1.06. In the year 2005, what is the difference between the Electricity production(% of total) of Cambodia and Electricity production(% of total) of Latvia?
Your answer should be compact. 93.76. In the year 2005, what is the difference between the Electricity production(% of total) of Cambodia and Electricity production(% of total) of Ukraine?
Your answer should be compact. 93.56. In the year 2005, what is the difference between the Electricity production(% of total) in Latvia and Electricity production(% of total) in Ukraine?
Keep it short and to the point. -0.19. In the year 2006, what is the difference between the Electricity production(% of total) in Bulgaria and Electricity production(% of total) in Cambodia?
Make the answer very short. -93.64. In the year 2006, what is the difference between the Electricity production(% of total) of Bulgaria and Electricity production(% of total) of Latvia?
Keep it short and to the point. 0.73. In the year 2006, what is the difference between the Electricity production(% of total) in Bulgaria and Electricity production(% of total) in Ukraine?
Your answer should be very brief. 0.47. In the year 2006, what is the difference between the Electricity production(% of total) of Cambodia and Electricity production(% of total) of Latvia?
Make the answer very short. 94.37. In the year 2006, what is the difference between the Electricity production(% of total) in Cambodia and Electricity production(% of total) in Ukraine?
Offer a terse response. 94.11. In the year 2006, what is the difference between the Electricity production(% of total) of Latvia and Electricity production(% of total) of Ukraine?
Your answer should be compact. -0.26. In the year 2007, what is the difference between the Electricity production(% of total) of Bulgaria and Electricity production(% of total) of Cambodia?
Your answer should be compact. -94.31. In the year 2007, what is the difference between the Electricity production(% of total) in Bulgaria and Electricity production(% of total) in Latvia?
Keep it short and to the point. 0.97. In the year 2007, what is the difference between the Electricity production(% of total) of Bulgaria and Electricity production(% of total) of Ukraine?
Your answer should be very brief. 0.94. In the year 2007, what is the difference between the Electricity production(% of total) in Cambodia and Electricity production(% of total) in Latvia?
Offer a very short reply. 95.28. In the year 2007, what is the difference between the Electricity production(% of total) in Cambodia and Electricity production(% of total) in Ukraine?
Make the answer very short. 95.25. In the year 2007, what is the difference between the Electricity production(% of total) of Latvia and Electricity production(% of total) of Ukraine?
Keep it short and to the point. -0.03. In the year 2008, what is the difference between the Electricity production(% of total) of Bulgaria and Electricity production(% of total) of Cambodia?
Provide a short and direct response. -95.19. In the year 2008, what is the difference between the Electricity production(% of total) of Bulgaria and Electricity production(% of total) of Latvia?
Your answer should be very brief. 0.58. In the year 2008, what is the difference between the Electricity production(% of total) in Bulgaria and Electricity production(% of total) in Ukraine?
Your response must be concise. 0.11. In the year 2008, what is the difference between the Electricity production(% of total) in Cambodia and Electricity production(% of total) in Latvia?
Keep it short and to the point. 95.77. In the year 2008, what is the difference between the Electricity production(% of total) of Cambodia and Electricity production(% of total) of Ukraine?
Keep it short and to the point. 95.3. In the year 2008, what is the difference between the Electricity production(% of total) in Latvia and Electricity production(% of total) in Ukraine?
Provide a succinct answer. -0.47. In the year 2009, what is the difference between the Electricity production(% of total) in Bulgaria and Electricity production(% of total) in Cambodia?
Your answer should be very brief. -92.38. In the year 2009, what is the difference between the Electricity production(% of total) of Bulgaria and Electricity production(% of total) of Latvia?
Offer a terse response. 0.7. In the year 2009, what is the difference between the Electricity production(% of total) of Bulgaria and Electricity production(% of total) of Ukraine?
Provide a succinct answer. -0.2. In the year 2009, what is the difference between the Electricity production(% of total) of Cambodia and Electricity production(% of total) of Latvia?
Your answer should be very brief. 93.08. In the year 2009, what is the difference between the Electricity production(% of total) of Cambodia and Electricity production(% of total) of Ukraine?
Give a very brief answer. 92.18. In the year 2009, what is the difference between the Electricity production(% of total) in Latvia and Electricity production(% of total) in Ukraine?
Provide a succinct answer. -0.9. In the year 2010, what is the difference between the Electricity production(% of total) of Bulgaria and Electricity production(% of total) of Cambodia?
Ensure brevity in your answer.  -91.1. In the year 2010, what is the difference between the Electricity production(% of total) in Bulgaria and Electricity production(% of total) in Latvia?
Your answer should be compact. 0.82. In the year 2010, what is the difference between the Electricity production(% of total) of Bulgaria and Electricity production(% of total) of Ukraine?
Your response must be concise. 0.42. In the year 2010, what is the difference between the Electricity production(% of total) of Cambodia and Electricity production(% of total) of Latvia?
Keep it short and to the point. 91.92. In the year 2010, what is the difference between the Electricity production(% of total) of Cambodia and Electricity production(% of total) of Ukraine?
Your response must be concise. 91.52. In the year 2010, what is the difference between the Electricity production(% of total) of Latvia and Electricity production(% of total) of Ukraine?
Provide a succinct answer. -0.41. What is the ratio of the Electricity production(% of total) in Bulgaria in 2003 to that in 2004?
Ensure brevity in your answer.  0.94. What is the ratio of the Electricity production(% of total) of Cambodia in 2003 to that in 2004?
Make the answer very short. 0.99. What is the ratio of the Electricity production(% of total) of Latvia in 2003 to that in 2004?
Offer a terse response. 1.61. What is the ratio of the Electricity production(% of total) of Ukraine in 2003 to that in 2004?
Make the answer very short. 1.15. What is the ratio of the Electricity production(% of total) of Bulgaria in 2003 to that in 2005?
Your answer should be compact. 1.35. What is the ratio of the Electricity production(% of total) of Latvia in 2003 to that in 2005?
Offer a terse response. 16.87. What is the ratio of the Electricity production(% of total) in Ukraine in 2003 to that in 2005?
Offer a terse response. 1.14. What is the ratio of the Electricity production(% of total) of Bulgaria in 2003 to that in 2006?
Your response must be concise. 2.24. What is the ratio of the Electricity production(% of total) in Cambodia in 2003 to that in 2006?
Give a very brief answer. 0.99. What is the ratio of the Electricity production(% of total) in Latvia in 2003 to that in 2006?
Ensure brevity in your answer.  20.18. What is the ratio of the Electricity production(% of total) in Ukraine in 2003 to that in 2006?
Provide a succinct answer. 1. What is the ratio of the Electricity production(% of total) of Bulgaria in 2003 to that in 2007?
Offer a very short reply. 1.41. What is the ratio of the Electricity production(% of total) of Cambodia in 2003 to that in 2007?
Offer a very short reply. 0.98. What is the ratio of the Electricity production(% of total) in Latvia in 2003 to that in 2007?
Your answer should be very brief. 5.79. What is the ratio of the Electricity production(% of total) in Ukraine in 2003 to that in 2007?
Your response must be concise. 0.93. What is the ratio of the Electricity production(% of total) of Bulgaria in 2003 to that in 2008?
Offer a very short reply. 3. What is the ratio of the Electricity production(% of total) in Cambodia in 2003 to that in 2008?
Your answer should be very brief. 0.98. What is the ratio of the Electricity production(% of total) in Latvia in 2003 to that in 2008?
Your response must be concise. 54.4. What is the ratio of the Electricity production(% of total) of Ukraine in 2003 to that in 2008?
Make the answer very short. 0.71. What is the ratio of the Electricity production(% of total) in Bulgaria in 2003 to that in 2009?
Keep it short and to the point. 2.41. What is the ratio of the Electricity production(% of total) of Cambodia in 2003 to that in 2009?
Your response must be concise. 1. What is the ratio of the Electricity production(% of total) of Latvia in 2003 to that in 2009?
Your answer should be compact. 28.72. What is the ratio of the Electricity production(% of total) in Ukraine in 2003 to that in 2009?
Provide a short and direct response. 0.37. What is the ratio of the Electricity production(% of total) of Bulgaria in 2003 to that in 2010?
Your answer should be very brief. 2.18. What is the ratio of the Electricity production(% of total) of Cambodia in 2003 to that in 2010?
Your response must be concise. 1.02. What is the ratio of the Electricity production(% of total) of Latvia in 2003 to that in 2010?
Your answer should be compact. 68.35. What is the ratio of the Electricity production(% of total) of Ukraine in 2003 to that in 2010?
Your answer should be compact. 0.83. What is the ratio of the Electricity production(% of total) in Bulgaria in 2004 to that in 2005?
Keep it short and to the point. 1.44. What is the ratio of the Electricity production(% of total) of Cambodia in 2004 to that in 2005?
Provide a succinct answer. 1.01. What is the ratio of the Electricity production(% of total) in Latvia in 2004 to that in 2005?
Keep it short and to the point. 10.46. What is the ratio of the Electricity production(% of total) in Ukraine in 2004 to that in 2005?
Make the answer very short. 0.99. What is the ratio of the Electricity production(% of total) in Bulgaria in 2004 to that in 2006?
Make the answer very short. 2.38. What is the ratio of the Electricity production(% of total) in Latvia in 2004 to that in 2006?
Make the answer very short. 12.52. What is the ratio of the Electricity production(% of total) of Ukraine in 2004 to that in 2006?
Ensure brevity in your answer.  0.87. What is the ratio of the Electricity production(% of total) in Cambodia in 2004 to that in 2007?
Provide a succinct answer. 0.99. What is the ratio of the Electricity production(% of total) in Latvia in 2004 to that in 2007?
Offer a terse response. 3.59. What is the ratio of the Electricity production(% of total) of Ukraine in 2004 to that in 2007?
Offer a terse response. 0.81. What is the ratio of the Electricity production(% of total) in Bulgaria in 2004 to that in 2008?
Keep it short and to the point. 3.19. What is the ratio of the Electricity production(% of total) in Cambodia in 2004 to that in 2008?
Your response must be concise. 0.99. What is the ratio of the Electricity production(% of total) of Latvia in 2004 to that in 2008?
Provide a succinct answer. 33.74. What is the ratio of the Electricity production(% of total) of Ukraine in 2004 to that in 2008?
Make the answer very short. 0.61. What is the ratio of the Electricity production(% of total) in Bulgaria in 2004 to that in 2009?
Your answer should be compact. 2.56. What is the ratio of the Electricity production(% of total) in Cambodia in 2004 to that in 2009?
Your response must be concise. 1.02. What is the ratio of the Electricity production(% of total) in Latvia in 2004 to that in 2009?
Your response must be concise. 17.82. What is the ratio of the Electricity production(% of total) in Ukraine in 2004 to that in 2009?
Offer a terse response. 0.32. What is the ratio of the Electricity production(% of total) of Bulgaria in 2004 to that in 2010?
Offer a terse response. 2.32. What is the ratio of the Electricity production(% of total) of Cambodia in 2004 to that in 2010?
Keep it short and to the point. 1.03. What is the ratio of the Electricity production(% of total) in Latvia in 2004 to that in 2010?
Your answer should be compact. 42.4. What is the ratio of the Electricity production(% of total) in Ukraine in 2004 to that in 2010?
Give a very brief answer. 0.72. What is the ratio of the Electricity production(% of total) in Bulgaria in 2005 to that in 2006?
Ensure brevity in your answer.  1.65. What is the ratio of the Electricity production(% of total) in Latvia in 2005 to that in 2006?
Your answer should be compact. 1.2. What is the ratio of the Electricity production(% of total) of Ukraine in 2005 to that in 2006?
Offer a very short reply. 0.88. What is the ratio of the Electricity production(% of total) of Bulgaria in 2005 to that in 2007?
Your answer should be very brief. 1.04. What is the ratio of the Electricity production(% of total) of Cambodia in 2005 to that in 2007?
Provide a short and direct response. 0.98. What is the ratio of the Electricity production(% of total) in Latvia in 2005 to that in 2007?
Ensure brevity in your answer.  0.34. What is the ratio of the Electricity production(% of total) of Ukraine in 2005 to that in 2007?
Your answer should be very brief. 0.81. What is the ratio of the Electricity production(% of total) in Bulgaria in 2005 to that in 2008?
Provide a short and direct response. 2.22. What is the ratio of the Electricity production(% of total) of Cambodia in 2005 to that in 2008?
Provide a short and direct response. 0.98. What is the ratio of the Electricity production(% of total) in Latvia in 2005 to that in 2008?
Your answer should be compact. 3.23. What is the ratio of the Electricity production(% of total) of Ukraine in 2005 to that in 2008?
Ensure brevity in your answer.  0.62. What is the ratio of the Electricity production(% of total) in Bulgaria in 2005 to that in 2009?
Provide a short and direct response. 1.78. What is the ratio of the Electricity production(% of total) in Cambodia in 2005 to that in 2009?
Ensure brevity in your answer.  1.01. What is the ratio of the Electricity production(% of total) in Latvia in 2005 to that in 2009?
Keep it short and to the point. 1.7. What is the ratio of the Electricity production(% of total) of Ukraine in 2005 to that in 2009?
Keep it short and to the point. 0.32. What is the ratio of the Electricity production(% of total) in Bulgaria in 2005 to that in 2010?
Your answer should be very brief. 1.61. What is the ratio of the Electricity production(% of total) of Latvia in 2005 to that in 2010?
Provide a succinct answer. 4.05. What is the ratio of the Electricity production(% of total) in Ukraine in 2005 to that in 2010?
Your answer should be compact. 0.72. What is the ratio of the Electricity production(% of total) of Bulgaria in 2006 to that in 2007?
Provide a short and direct response. 0.63. What is the ratio of the Electricity production(% of total) of Cambodia in 2006 to that in 2007?
Your answer should be compact. 0.99. What is the ratio of the Electricity production(% of total) in Latvia in 2006 to that in 2007?
Offer a very short reply. 0.29. What is the ratio of the Electricity production(% of total) in Ukraine in 2006 to that in 2007?
Your response must be concise. 0.93. What is the ratio of the Electricity production(% of total) of Bulgaria in 2006 to that in 2008?
Your answer should be compact. 1.34. What is the ratio of the Electricity production(% of total) in Cambodia in 2006 to that in 2008?
Ensure brevity in your answer.  0.99. What is the ratio of the Electricity production(% of total) of Latvia in 2006 to that in 2008?
Provide a succinct answer. 2.7. What is the ratio of the Electricity production(% of total) in Ukraine in 2006 to that in 2008?
Your answer should be very brief. 0.71. What is the ratio of the Electricity production(% of total) in Bulgaria in 2006 to that in 2009?
Your answer should be very brief. 1.08. What is the ratio of the Electricity production(% of total) in Cambodia in 2006 to that in 2009?
Make the answer very short. 1.01. What is the ratio of the Electricity production(% of total) in Latvia in 2006 to that in 2009?
Ensure brevity in your answer.  1.42. What is the ratio of the Electricity production(% of total) of Ukraine in 2006 to that in 2009?
Your answer should be compact. 0.37. What is the ratio of the Electricity production(% of total) in Bulgaria in 2006 to that in 2010?
Offer a terse response. 0.98. What is the ratio of the Electricity production(% of total) of Cambodia in 2006 to that in 2010?
Ensure brevity in your answer.  1.03. What is the ratio of the Electricity production(% of total) of Latvia in 2006 to that in 2010?
Keep it short and to the point. 3.39. What is the ratio of the Electricity production(% of total) of Ukraine in 2006 to that in 2010?
Make the answer very short. 0.83. What is the ratio of the Electricity production(% of total) of Bulgaria in 2007 to that in 2008?
Offer a very short reply. 2.13. What is the ratio of the Electricity production(% of total) of Latvia in 2007 to that in 2008?
Provide a succinct answer. 9.4. What is the ratio of the Electricity production(% of total) of Ukraine in 2007 to that in 2008?
Keep it short and to the point. 0.76. What is the ratio of the Electricity production(% of total) in Bulgaria in 2007 to that in 2009?
Your response must be concise. 1.71. What is the ratio of the Electricity production(% of total) in Cambodia in 2007 to that in 2009?
Keep it short and to the point. 1.03. What is the ratio of the Electricity production(% of total) of Latvia in 2007 to that in 2009?
Your answer should be compact. 4.96. What is the ratio of the Electricity production(% of total) of Ukraine in 2007 to that in 2009?
Your answer should be very brief. 0.4. What is the ratio of the Electricity production(% of total) in Bulgaria in 2007 to that in 2010?
Give a very brief answer. 1.55. What is the ratio of the Electricity production(% of total) of Cambodia in 2007 to that in 2010?
Give a very brief answer. 1.04. What is the ratio of the Electricity production(% of total) in Latvia in 2007 to that in 2010?
Provide a succinct answer. 11.81. What is the ratio of the Electricity production(% of total) of Ukraine in 2007 to that in 2010?
Your answer should be very brief. 0.89. What is the ratio of the Electricity production(% of total) of Bulgaria in 2008 to that in 2009?
Keep it short and to the point. 0.8. What is the ratio of the Electricity production(% of total) of Cambodia in 2008 to that in 2009?
Keep it short and to the point. 1.03. What is the ratio of the Electricity production(% of total) of Latvia in 2008 to that in 2009?
Keep it short and to the point. 0.53. What is the ratio of the Electricity production(% of total) of Ukraine in 2008 to that in 2009?
Your response must be concise. 0.52. What is the ratio of the Electricity production(% of total) of Bulgaria in 2008 to that in 2010?
Your answer should be very brief. 0.73. What is the ratio of the Electricity production(% of total) in Cambodia in 2008 to that in 2010?
Provide a short and direct response. 1.04. What is the ratio of the Electricity production(% of total) of Latvia in 2008 to that in 2010?
Provide a short and direct response. 1.26. What is the ratio of the Electricity production(% of total) of Ukraine in 2008 to that in 2010?
Provide a succinct answer. 1.17. What is the ratio of the Electricity production(% of total) in Bulgaria in 2009 to that in 2010?
Provide a succinct answer. 0.91. What is the ratio of the Electricity production(% of total) in Cambodia in 2009 to that in 2010?
Your response must be concise. 1.01. What is the ratio of the Electricity production(% of total) in Latvia in 2009 to that in 2010?
Offer a very short reply. 2.38. What is the ratio of the Electricity production(% of total) of Ukraine in 2009 to that in 2010?
Your answer should be very brief. 2.24. What is the difference between the highest and the second highest Electricity production(% of total) of Bulgaria?
Ensure brevity in your answer.  0.12. What is the difference between the highest and the second highest Electricity production(% of total) of Cambodia?
Give a very brief answer. 0.17. What is the difference between the highest and the second highest Electricity production(% of total) of Latvia?
Your answer should be very brief. 0.78. What is the difference between the highest and the second highest Electricity production(% of total) of Ukraine?
Make the answer very short. 0.47. What is the difference between the highest and the lowest Electricity production(% of total) in Bulgaria?
Make the answer very short. 1.36. What is the difference between the highest and the lowest Electricity production(% of total) in Cambodia?
Your answer should be very brief. 3.86. What is the difference between the highest and the lowest Electricity production(% of total) of Latvia?
Provide a succinct answer. 2.03. What is the difference between the highest and the lowest Electricity production(% of total) of Ukraine?
Provide a short and direct response. 0.66. 